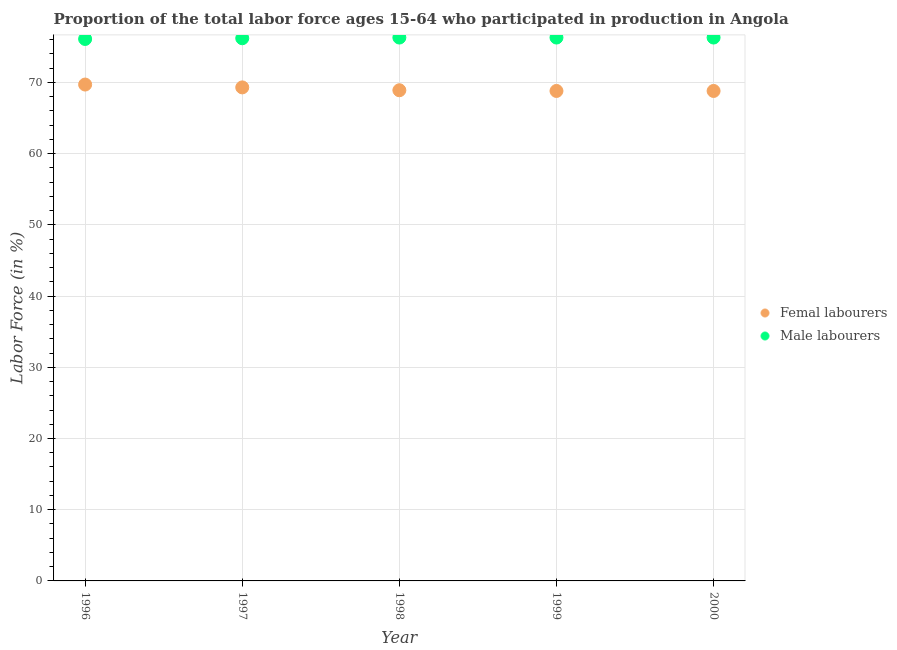How many different coloured dotlines are there?
Your answer should be very brief. 2. What is the percentage of female labor force in 1999?
Provide a succinct answer. 68.8. Across all years, what is the maximum percentage of female labor force?
Provide a short and direct response. 69.7. Across all years, what is the minimum percentage of male labour force?
Give a very brief answer. 76.1. In which year was the percentage of male labour force maximum?
Make the answer very short. 1998. What is the total percentage of female labor force in the graph?
Provide a succinct answer. 345.5. What is the difference between the percentage of male labour force in 1997 and that in 1999?
Keep it short and to the point. -0.1. What is the difference between the percentage of male labour force in 1998 and the percentage of female labor force in 2000?
Your answer should be very brief. 7.5. What is the average percentage of male labour force per year?
Give a very brief answer. 76.24. In the year 1999, what is the difference between the percentage of female labor force and percentage of male labour force?
Your answer should be very brief. -7.5. In how many years, is the percentage of male labour force greater than 46 %?
Ensure brevity in your answer.  5. What is the ratio of the percentage of male labour force in 1996 to that in 1999?
Ensure brevity in your answer.  1. Is the percentage of male labour force in 1996 less than that in 1997?
Your answer should be compact. Yes. Is the difference between the percentage of female labor force in 1999 and 2000 greater than the difference between the percentage of male labour force in 1999 and 2000?
Keep it short and to the point. No. What is the difference between the highest and the second highest percentage of female labor force?
Offer a terse response. 0.4. What is the difference between the highest and the lowest percentage of female labor force?
Keep it short and to the point. 0.9. Is the percentage of female labor force strictly less than the percentage of male labour force over the years?
Make the answer very short. Yes. How many dotlines are there?
Give a very brief answer. 2. Does the graph contain grids?
Your response must be concise. Yes. How many legend labels are there?
Your response must be concise. 2. What is the title of the graph?
Give a very brief answer. Proportion of the total labor force ages 15-64 who participated in production in Angola. Does "Nitrous oxide emissions" appear as one of the legend labels in the graph?
Give a very brief answer. No. What is the label or title of the Y-axis?
Your response must be concise. Labor Force (in %). What is the Labor Force (in %) in Femal labourers in 1996?
Offer a terse response. 69.7. What is the Labor Force (in %) in Male labourers in 1996?
Provide a short and direct response. 76.1. What is the Labor Force (in %) of Femal labourers in 1997?
Give a very brief answer. 69.3. What is the Labor Force (in %) in Male labourers in 1997?
Offer a terse response. 76.2. What is the Labor Force (in %) of Femal labourers in 1998?
Offer a very short reply. 68.9. What is the Labor Force (in %) of Male labourers in 1998?
Ensure brevity in your answer.  76.3. What is the Labor Force (in %) in Femal labourers in 1999?
Keep it short and to the point. 68.8. What is the Labor Force (in %) in Male labourers in 1999?
Offer a very short reply. 76.3. What is the Labor Force (in %) of Femal labourers in 2000?
Keep it short and to the point. 68.8. What is the Labor Force (in %) in Male labourers in 2000?
Ensure brevity in your answer.  76.3. Across all years, what is the maximum Labor Force (in %) in Femal labourers?
Offer a terse response. 69.7. Across all years, what is the maximum Labor Force (in %) of Male labourers?
Ensure brevity in your answer.  76.3. Across all years, what is the minimum Labor Force (in %) in Femal labourers?
Keep it short and to the point. 68.8. Across all years, what is the minimum Labor Force (in %) of Male labourers?
Your response must be concise. 76.1. What is the total Labor Force (in %) of Femal labourers in the graph?
Offer a very short reply. 345.5. What is the total Labor Force (in %) in Male labourers in the graph?
Provide a succinct answer. 381.2. What is the difference between the Labor Force (in %) of Femal labourers in 1996 and that in 1998?
Keep it short and to the point. 0.8. What is the difference between the Labor Force (in %) of Male labourers in 1996 and that in 1998?
Provide a succinct answer. -0.2. What is the difference between the Labor Force (in %) in Male labourers in 1996 and that in 1999?
Provide a short and direct response. -0.2. What is the difference between the Labor Force (in %) of Male labourers in 1996 and that in 2000?
Make the answer very short. -0.2. What is the difference between the Labor Force (in %) of Femal labourers in 1997 and that in 1998?
Your answer should be compact. 0.4. What is the difference between the Labor Force (in %) in Male labourers in 1997 and that in 1998?
Ensure brevity in your answer.  -0.1. What is the difference between the Labor Force (in %) of Femal labourers in 1998 and that in 1999?
Make the answer very short. 0.1. What is the difference between the Labor Force (in %) of Male labourers in 1998 and that in 2000?
Your answer should be compact. 0. What is the difference between the Labor Force (in %) in Femal labourers in 1999 and that in 2000?
Offer a very short reply. 0. What is the difference between the Labor Force (in %) in Femal labourers in 1997 and the Labor Force (in %) in Male labourers in 1998?
Offer a terse response. -7. What is the difference between the Labor Force (in %) of Femal labourers in 1998 and the Labor Force (in %) of Male labourers in 1999?
Give a very brief answer. -7.4. What is the difference between the Labor Force (in %) of Femal labourers in 1999 and the Labor Force (in %) of Male labourers in 2000?
Keep it short and to the point. -7.5. What is the average Labor Force (in %) of Femal labourers per year?
Provide a short and direct response. 69.1. What is the average Labor Force (in %) in Male labourers per year?
Offer a terse response. 76.24. In the year 1998, what is the difference between the Labor Force (in %) of Femal labourers and Labor Force (in %) of Male labourers?
Ensure brevity in your answer.  -7.4. In the year 1999, what is the difference between the Labor Force (in %) of Femal labourers and Labor Force (in %) of Male labourers?
Offer a very short reply. -7.5. What is the ratio of the Labor Force (in %) of Femal labourers in 1996 to that in 1997?
Give a very brief answer. 1.01. What is the ratio of the Labor Force (in %) of Femal labourers in 1996 to that in 1998?
Give a very brief answer. 1.01. What is the ratio of the Labor Force (in %) of Femal labourers in 1996 to that in 1999?
Offer a very short reply. 1.01. What is the ratio of the Labor Force (in %) in Femal labourers in 1996 to that in 2000?
Ensure brevity in your answer.  1.01. What is the ratio of the Labor Force (in %) in Male labourers in 1996 to that in 2000?
Ensure brevity in your answer.  1. What is the ratio of the Labor Force (in %) of Femal labourers in 1997 to that in 1998?
Make the answer very short. 1.01. What is the ratio of the Labor Force (in %) of Femal labourers in 1997 to that in 1999?
Provide a short and direct response. 1.01. What is the ratio of the Labor Force (in %) in Femal labourers in 1997 to that in 2000?
Provide a short and direct response. 1.01. What is the ratio of the Labor Force (in %) of Male labourers in 1997 to that in 2000?
Keep it short and to the point. 1. What is the ratio of the Labor Force (in %) in Femal labourers in 1998 to that in 1999?
Give a very brief answer. 1. What is the ratio of the Labor Force (in %) in Femal labourers in 1998 to that in 2000?
Your answer should be very brief. 1. What is the ratio of the Labor Force (in %) in Femal labourers in 1999 to that in 2000?
Your answer should be very brief. 1. What is the difference between the highest and the second highest Labor Force (in %) of Femal labourers?
Your response must be concise. 0.4. What is the difference between the highest and the second highest Labor Force (in %) in Male labourers?
Your answer should be compact. 0. What is the difference between the highest and the lowest Labor Force (in %) in Femal labourers?
Offer a very short reply. 0.9. 